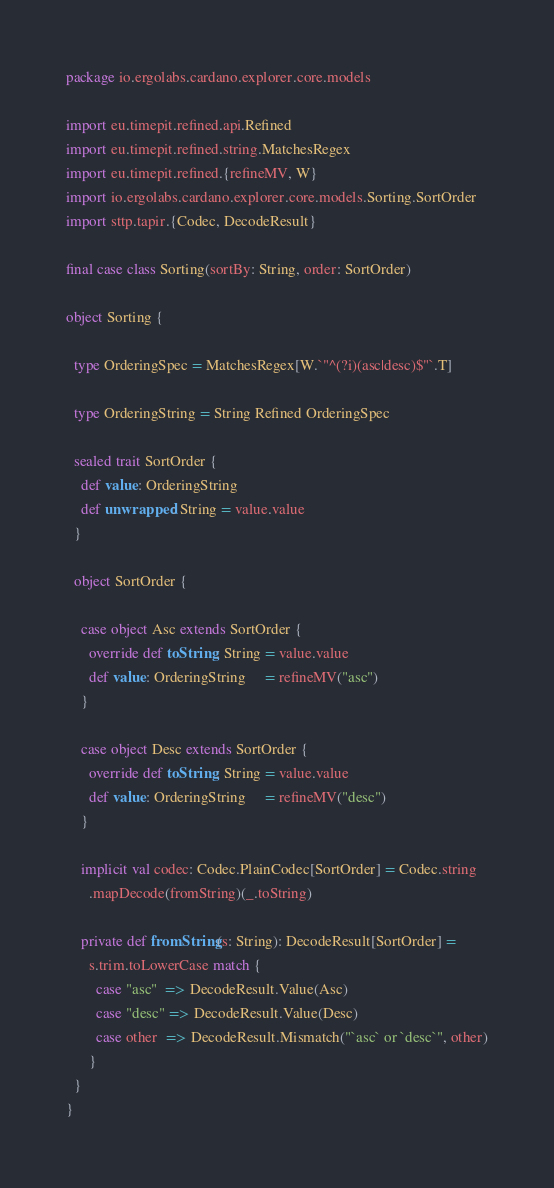<code> <loc_0><loc_0><loc_500><loc_500><_Scala_>package io.ergolabs.cardano.explorer.core.models

import eu.timepit.refined.api.Refined
import eu.timepit.refined.string.MatchesRegex
import eu.timepit.refined.{refineMV, W}
import io.ergolabs.cardano.explorer.core.models.Sorting.SortOrder
import sttp.tapir.{Codec, DecodeResult}

final case class Sorting(sortBy: String, order: SortOrder)

object Sorting {

  type OrderingSpec = MatchesRegex[W.`"^(?i)(asc|desc)$"`.T]

  type OrderingString = String Refined OrderingSpec

  sealed trait SortOrder {
    def value: OrderingString
    def unwrapped: String = value.value
  }

  object SortOrder {

    case object Asc extends SortOrder {
      override def toString: String = value.value
      def value: OrderingString     = refineMV("asc")
    }

    case object Desc extends SortOrder {
      override def toString: String = value.value
      def value: OrderingString     = refineMV("desc")
    }

    implicit val codec: Codec.PlainCodec[SortOrder] = Codec.string
      .mapDecode(fromString)(_.toString)

    private def fromString(s: String): DecodeResult[SortOrder] =
      s.trim.toLowerCase match {
        case "asc"  => DecodeResult.Value(Asc)
        case "desc" => DecodeResult.Value(Desc)
        case other  => DecodeResult.Mismatch("`asc` or `desc`", other)
      }
  }
}
</code> 